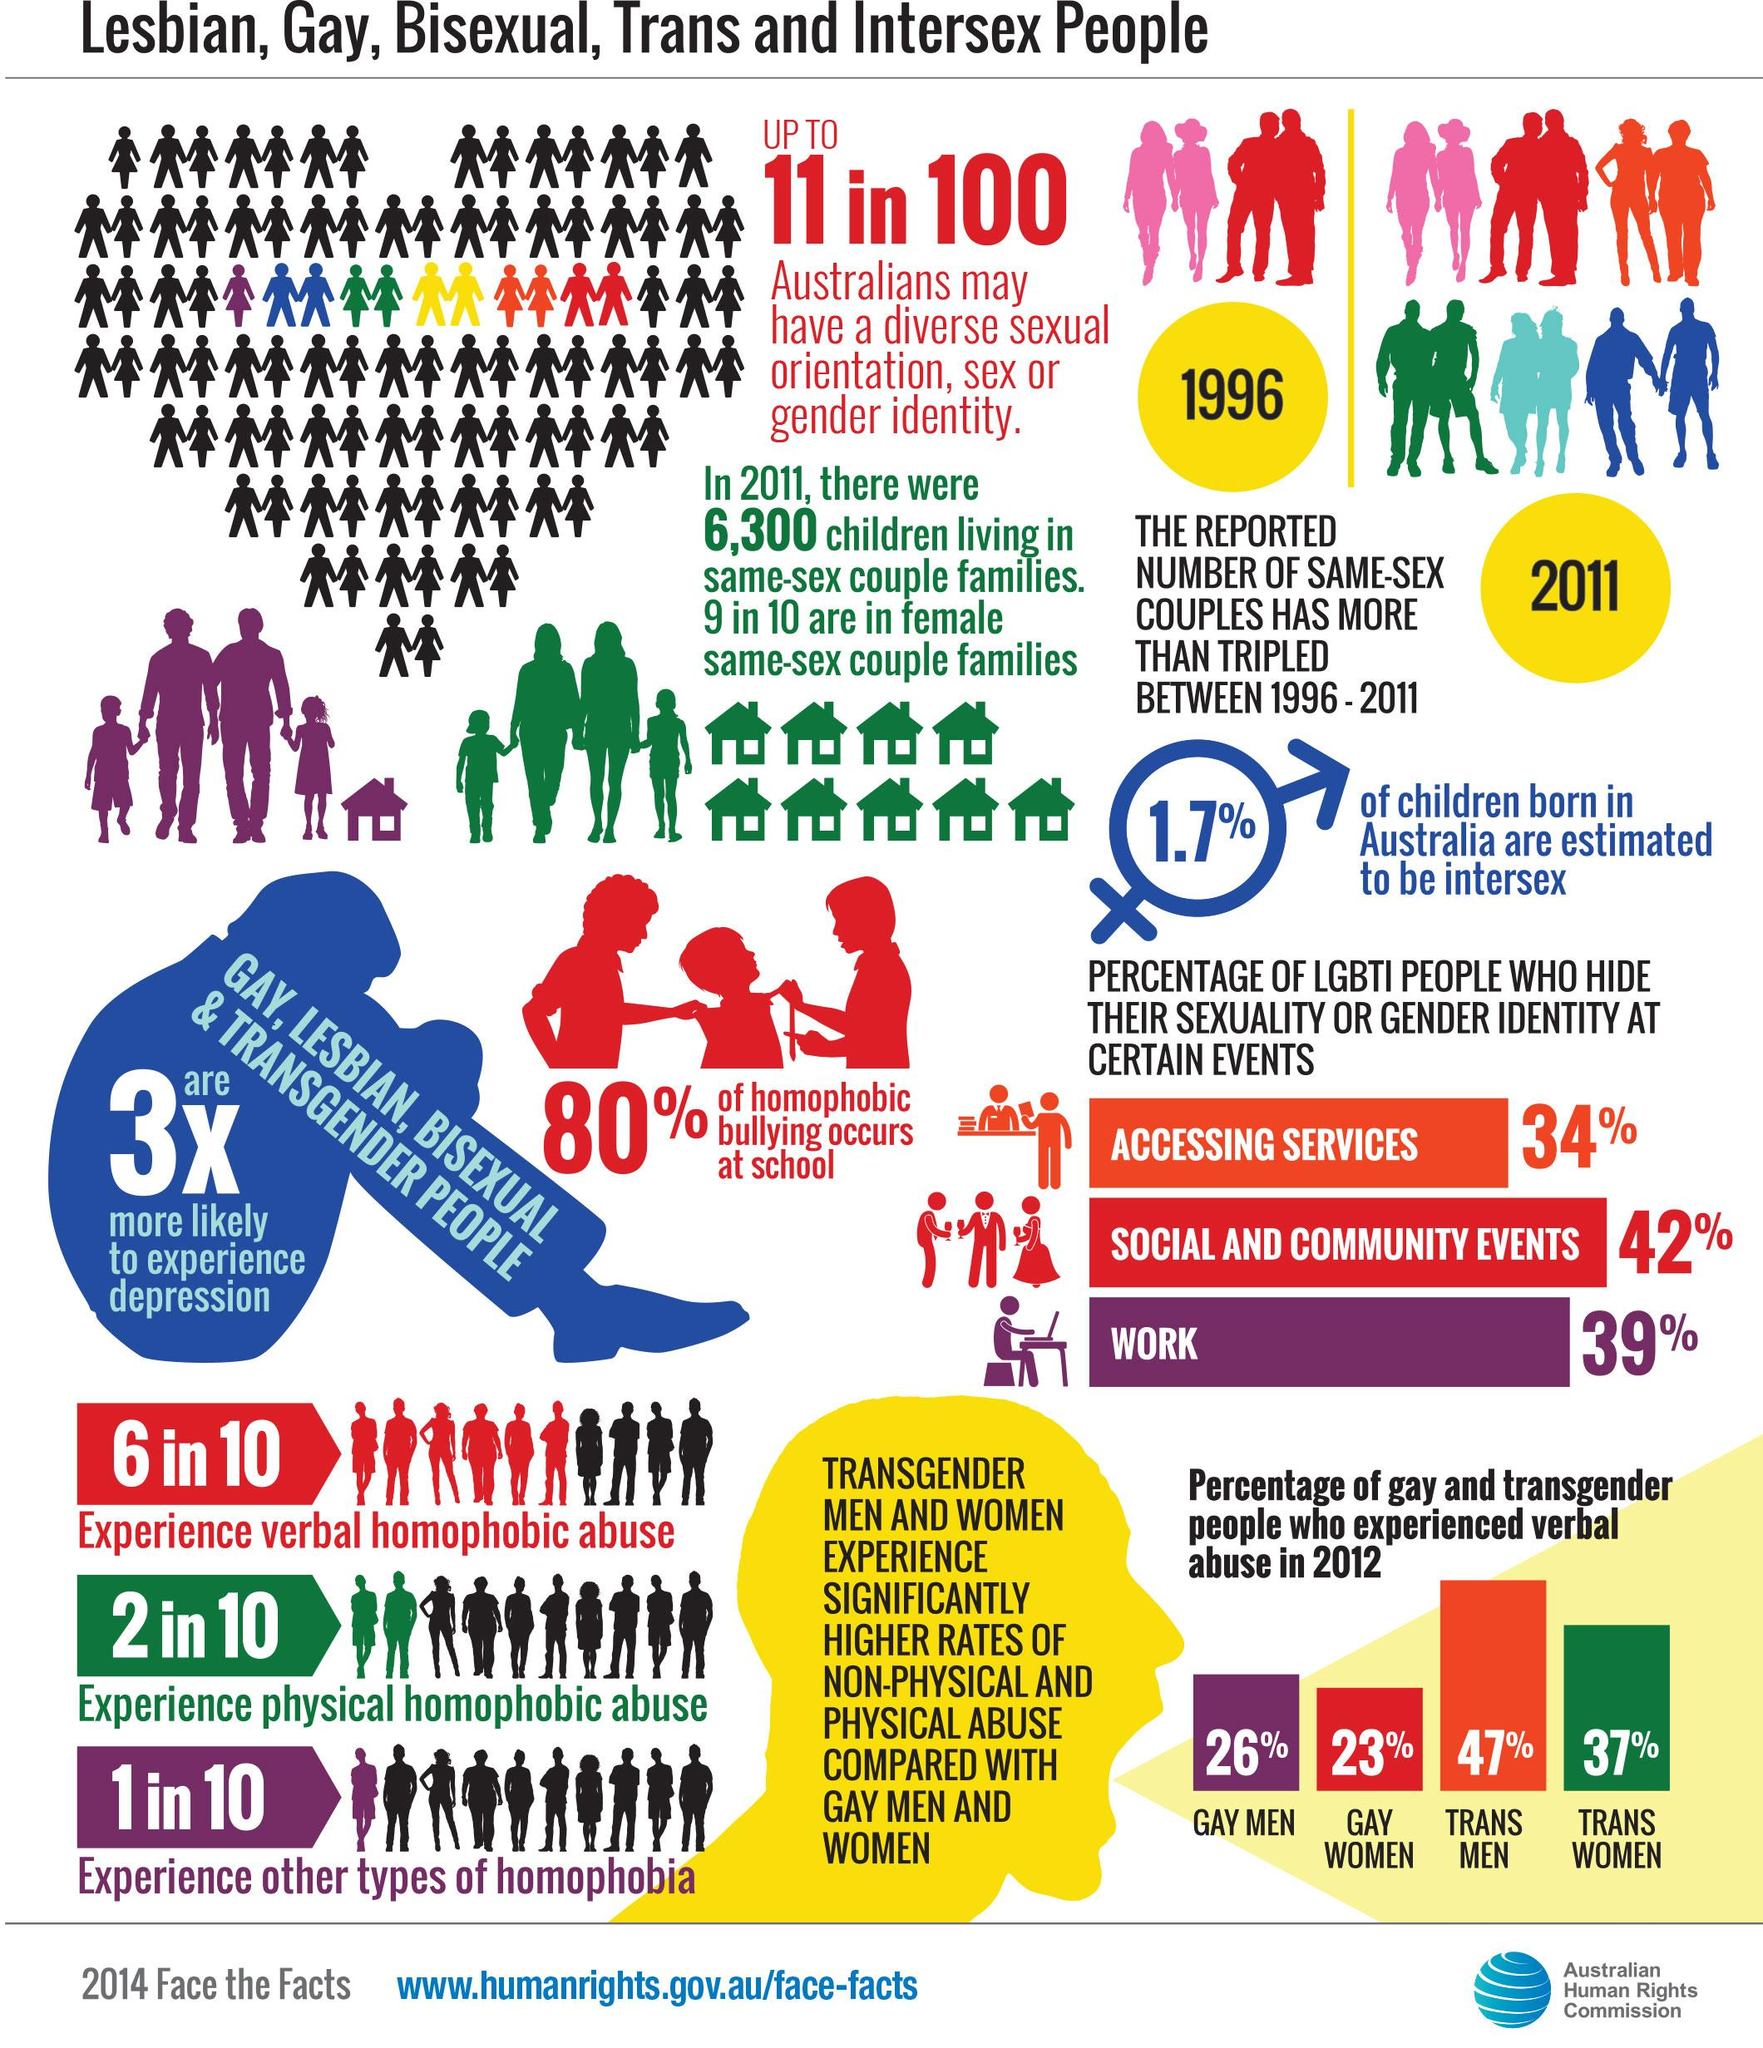List a handful of essential elements in this visual. According to data from 2011, approximately 90% of 6,300 children were part of female same-sex couple families. LGBTI individuals often hide their sexuality at social and community events due to fear of discrimination and stigmatization. In 2012, the group of LGBTI people who experienced verbal abuse the third most were gay men. According to data collected in 2012, trans women were the second group of LGBTI individuals to experience the most verbal abuse. In 2012, trans men were the group of LGBTI individuals who experienced the most verbal abuse. 